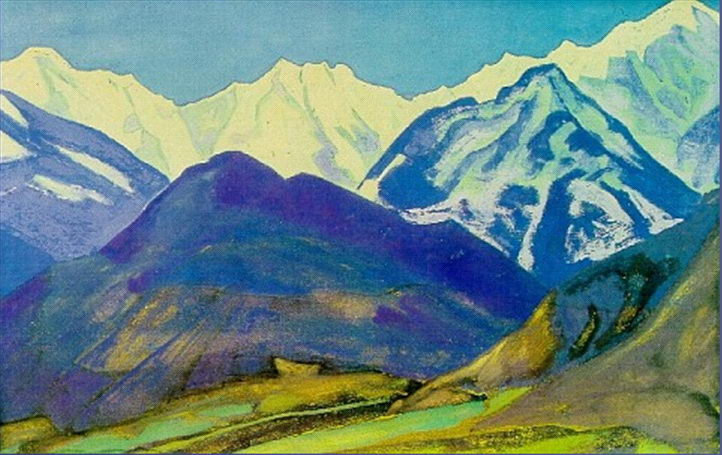Analyze the image in a comprehensive and detailed manner. The image depicts a mountain landscape rendered in a post-impressionist style. The mountains, painted in various shades of blue, green, and purple, dominate the scene, their snow-capped peaks fading into the background. The foreground features a verdant valley, punctuated by a small body of water. The use of bright and vibrant colors throughout the piece creates a sense of depth and distance. The artist's loose brushstrokes and bold use of color are characteristic of the post-impressionist genre. The overall composition and color palette evoke a sense of tranquility and natural beauty. 